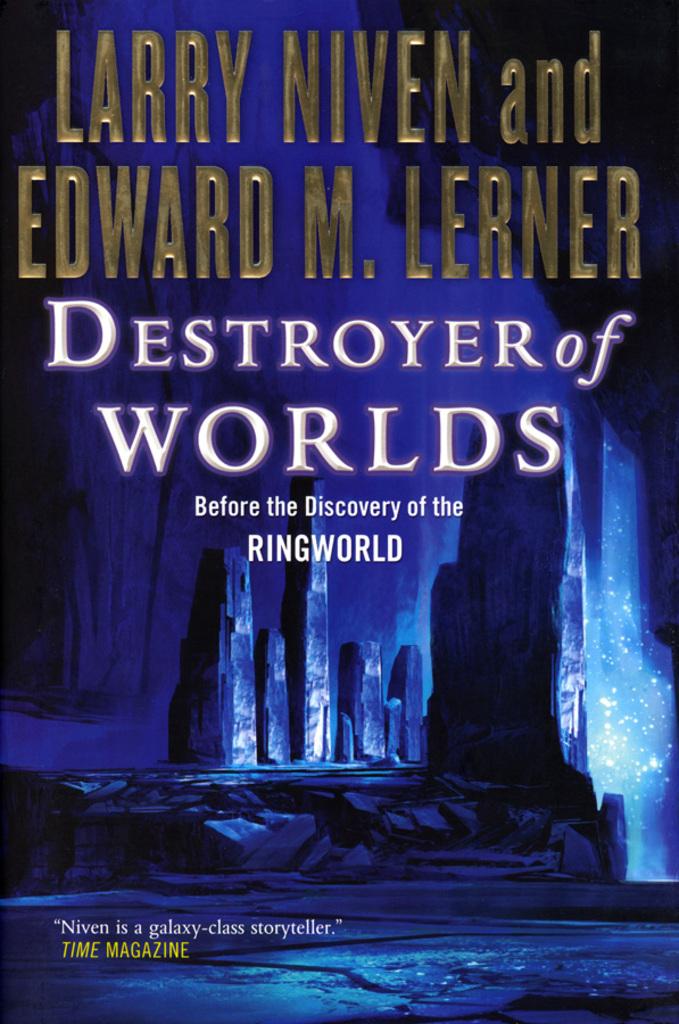Who wrote the review for this book?
Offer a very short reply. Time magazine. What is the title?
Offer a terse response. Destroyer of worlds. 